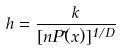Convert formula to latex. <formula><loc_0><loc_0><loc_500><loc_500>h = \frac { k } { [ n P ( \vec { x } ) ] ^ { 1 / D } }</formula> 